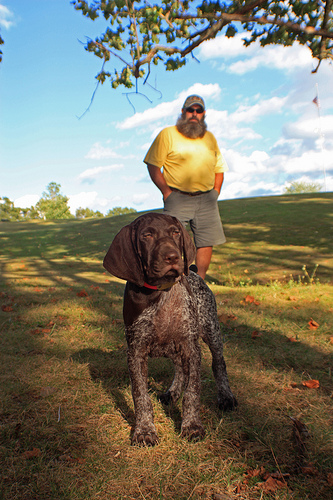Please provide a bounding box coordinate of the region this sentence describes: He has a yellow shirt. The bounding box coordinates for the man wearing a vibrant yellow shirt are [0.46, 0.2, 0.65, 0.4]. 